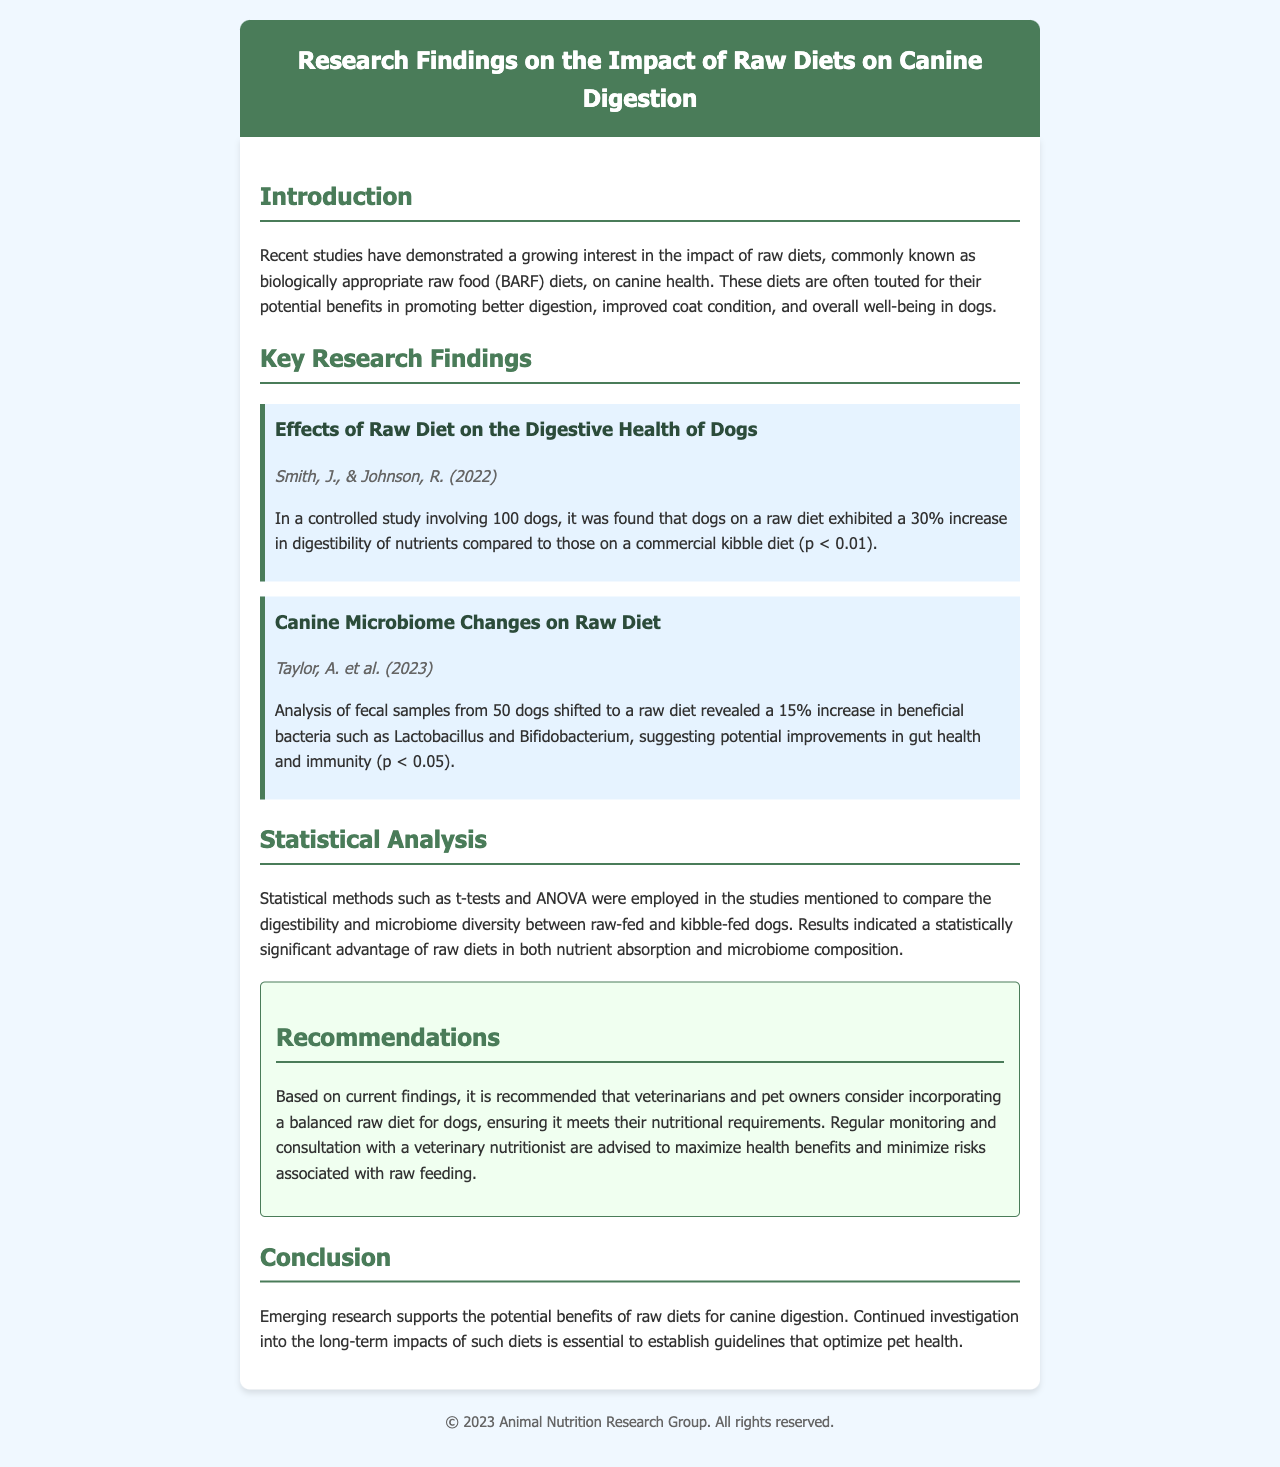What is the title of the document? The title is found in the header of the document.
Answer: Research Findings on the Impact of Raw Diets on Canine Digestion How many dogs were involved in the study by Smith and Johnson? The number of dogs is stated in the findings of their study.
Answer: 100 What was the percentage increase in nutrient digestibility for raw-fed dogs? This percentage is mentioned in the key research findings section.
Answer: 30% Who authored the study analyzing fecal samples from dogs on a raw diet? The authors of this study are listed in the document.
Answer: Taylor, A. et al What methodological tests were used in the statistical analysis? The tests employed for the analysis are specified in the statistical methods section.
Answer: t-tests and ANOVA What specific bacteria group showed an increase in raw-fed dogs? The beneficial bacteria group mentioned in the study regarding microbiome changes.
Answer: Lactobacillus and Bifidobacterium What is recommended to maximize health benefits when feeding dogs a raw diet? The recommendations section advises on practices for feeding a raw diet.
Answer: Regular monitoring and consultation with a veterinary nutritionist What is the publication year of the study by Smith and Johnson? The publication year is included with the citation of their study.
Answer: 2022 What is the main conclusion of the document? The conclusion summarizes the overall findings of the research discussed.
Answer: Emerging research supports the potential benefits of raw diets for canine digestion 